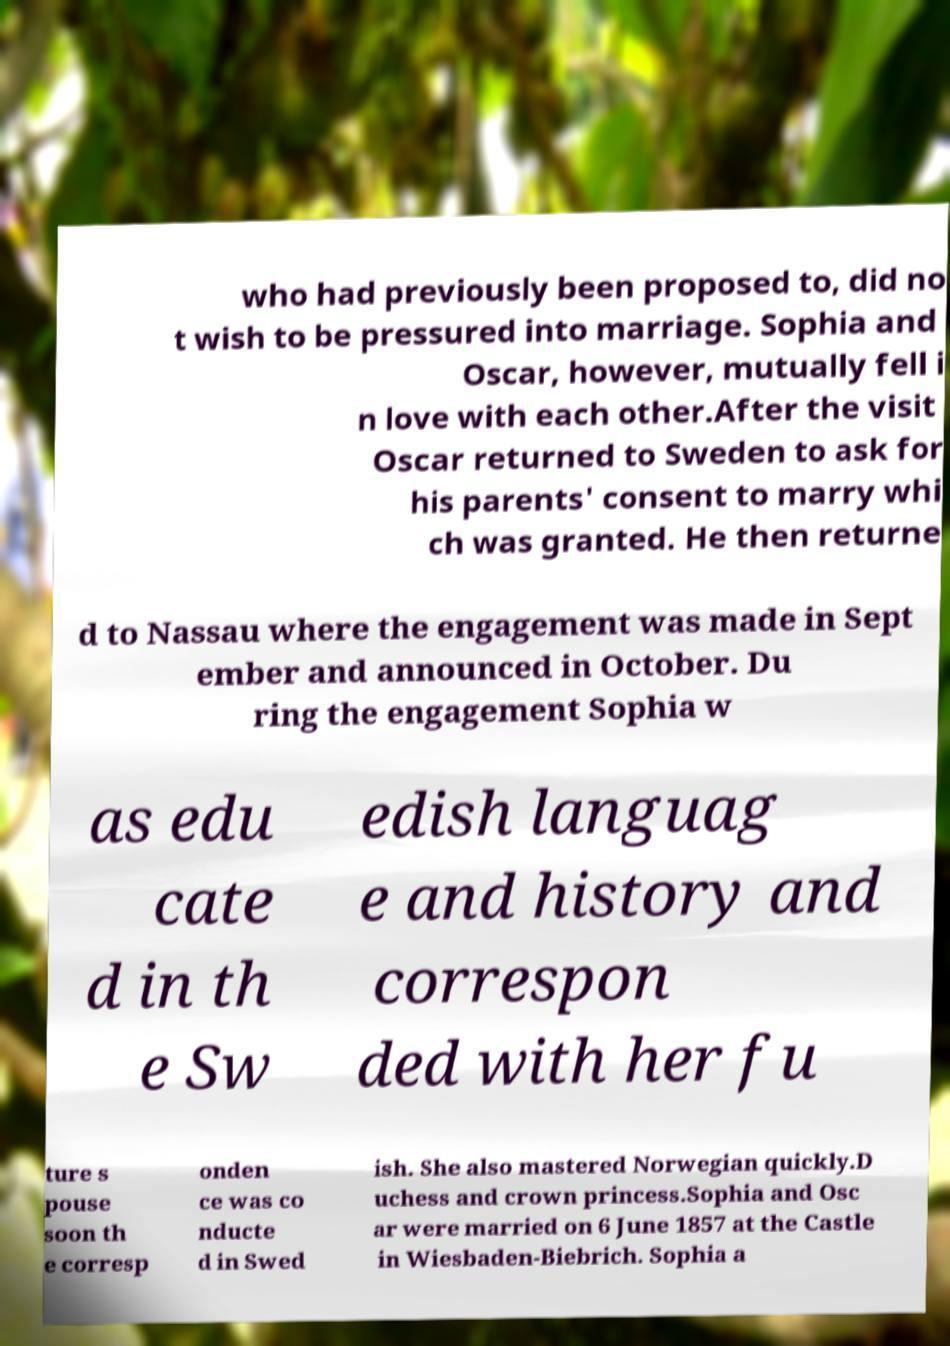Please identify and transcribe the text found in this image. who had previously been proposed to, did no t wish to be pressured into marriage. Sophia and Oscar, however, mutually fell i n love with each other.After the visit Oscar returned to Sweden to ask for his parents' consent to marry whi ch was granted. He then returne d to Nassau where the engagement was made in Sept ember and announced in October. Du ring the engagement Sophia w as edu cate d in th e Sw edish languag e and history and correspon ded with her fu ture s pouse soon th e corresp onden ce was co nducte d in Swed ish. She also mastered Norwegian quickly.D uchess and crown princess.Sophia and Osc ar were married on 6 June 1857 at the Castle in Wiesbaden-Biebrich. Sophia a 